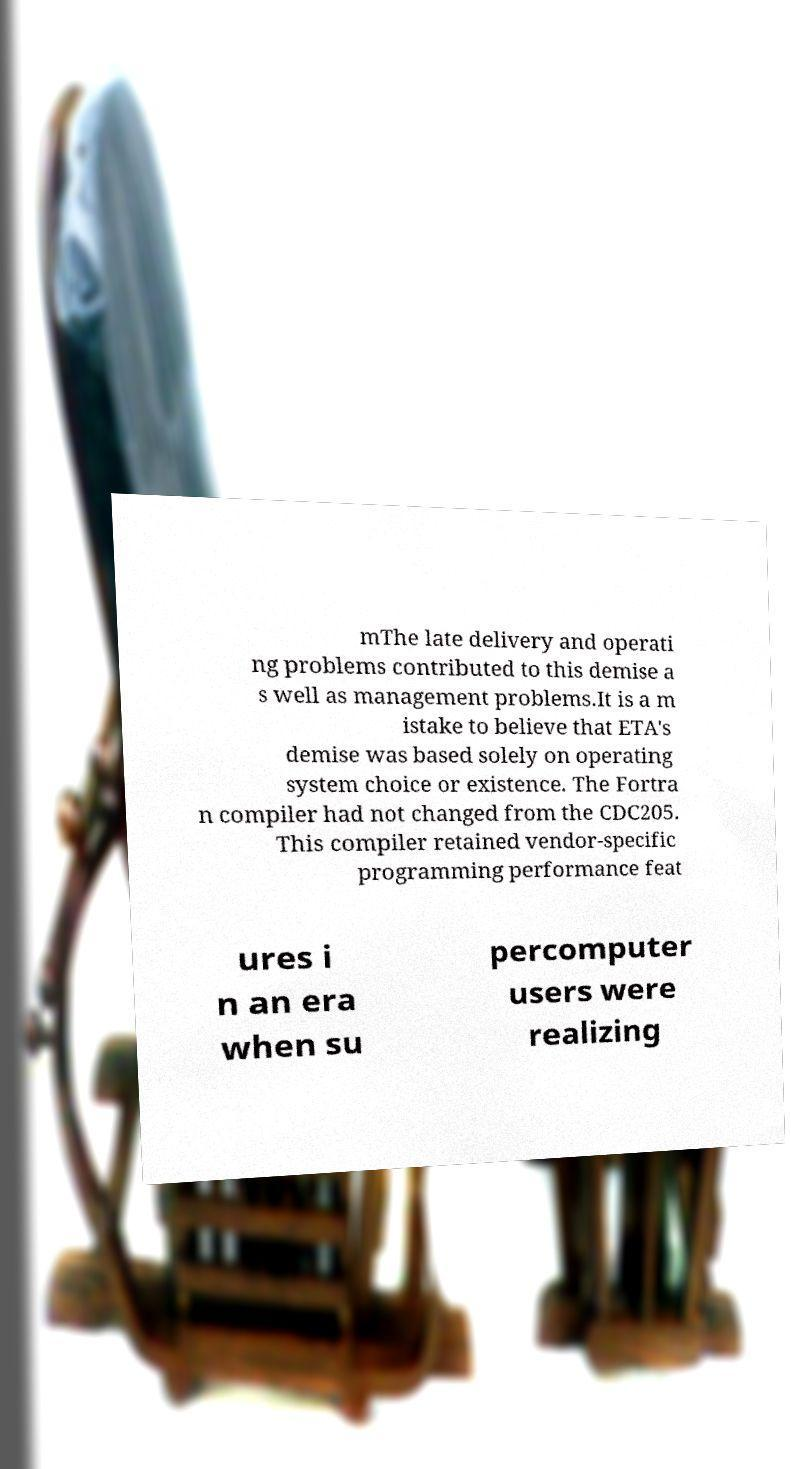There's text embedded in this image that I need extracted. Can you transcribe it verbatim? mThe late delivery and operati ng problems contributed to this demise a s well as management problems.It is a m istake to believe that ETA's demise was based solely on operating system choice or existence. The Fortra n compiler had not changed from the CDC205. This compiler retained vendor-specific programming performance feat ures i n an era when su percomputer users were realizing 